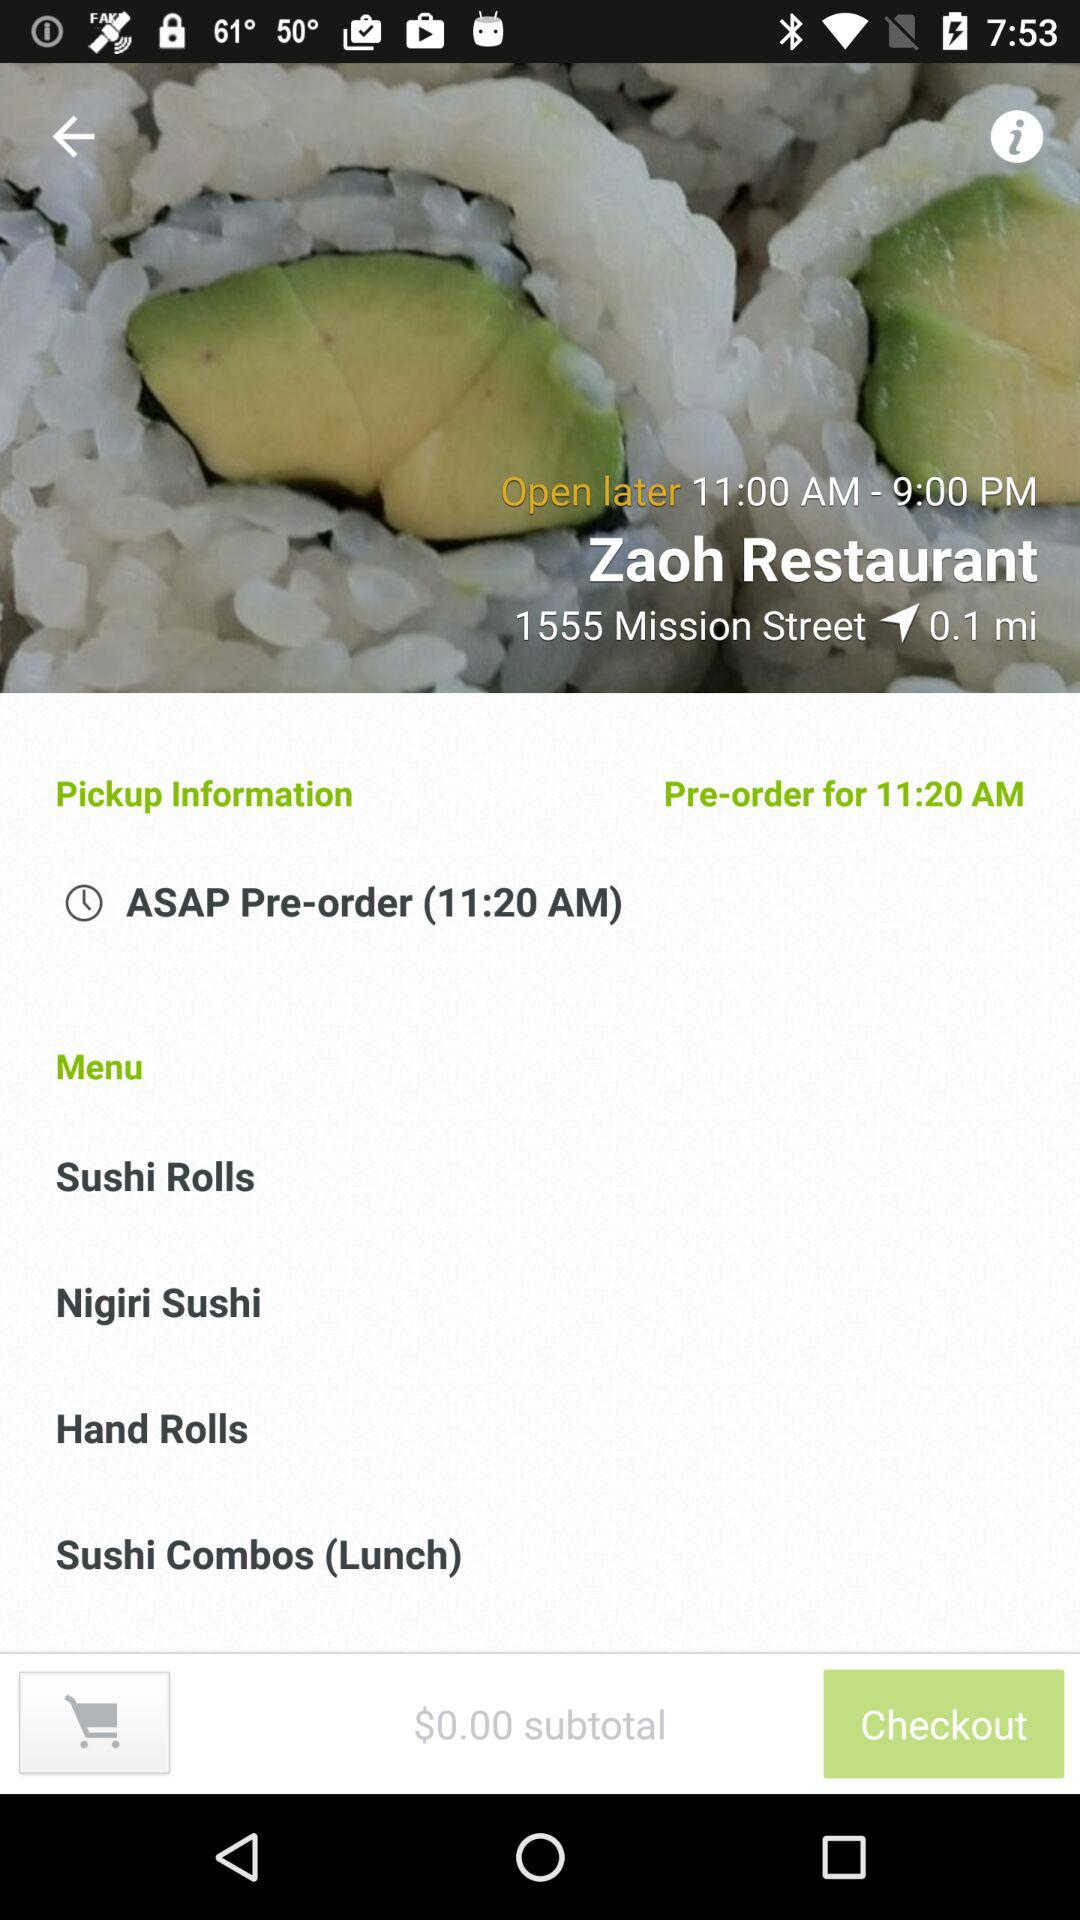What is the distance of the restaurant from the source location? The distance between the restaurant and the source location is 0.1 mile. 